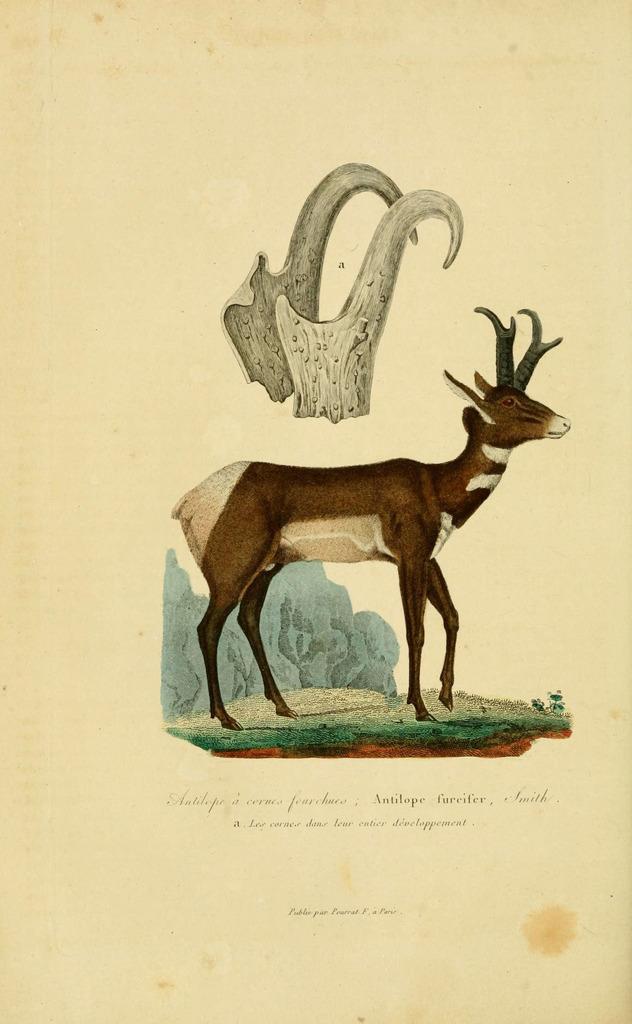Can you describe this image briefly? In this picture I can see there is drawing of a deer standing on the grass and there is a rock in the backdrop, there is another image at the top of the image. There is something written at the bottom of the image. 